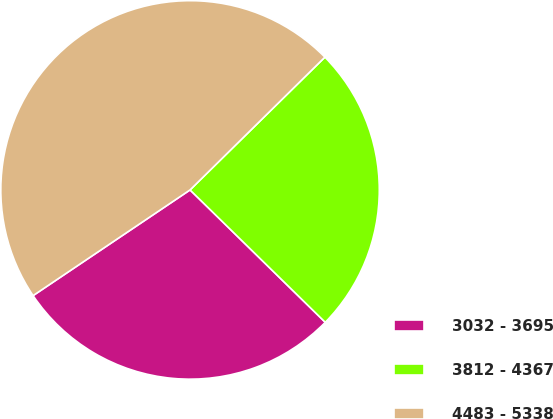<chart> <loc_0><loc_0><loc_500><loc_500><pie_chart><fcel>3032 - 3695<fcel>3812 - 4367<fcel>4483 - 5338<nl><fcel>28.24%<fcel>24.71%<fcel>47.06%<nl></chart> 